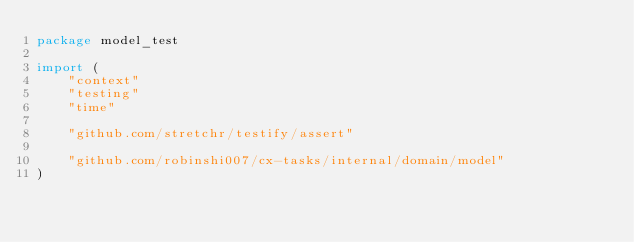<code> <loc_0><loc_0><loc_500><loc_500><_Go_>package model_test

import (
	"context"
	"testing"
	"time"

	"github.com/stretchr/testify/assert"

	"github.com/robinshi007/cx-tasks/internal/domain/model"
)
</code> 